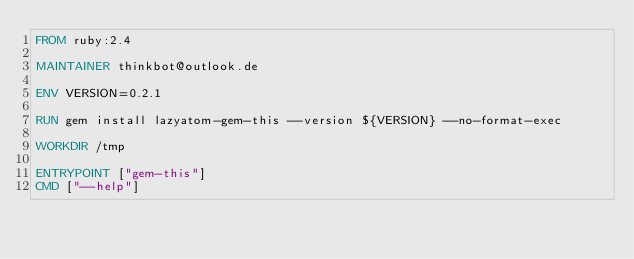<code> <loc_0><loc_0><loc_500><loc_500><_Dockerfile_>FROM ruby:2.4

MAINTAINER thinkbot@outlook.de

ENV VERSION=0.2.1

RUN gem install lazyatom-gem-this --version ${VERSION} --no-format-exec

WORKDIR /tmp

ENTRYPOINT ["gem-this"]
CMD ["--help"]
</code> 